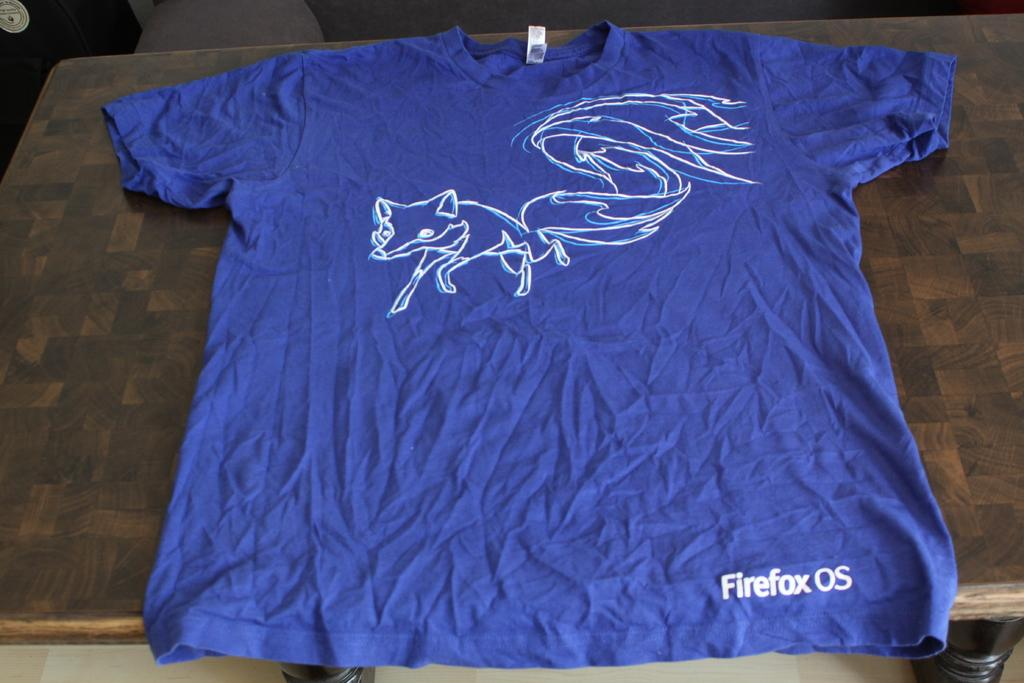<image>
Render a clear and concise summary of the photo. A blue t-shirt has a picture of a fox for the Firefox OS. 